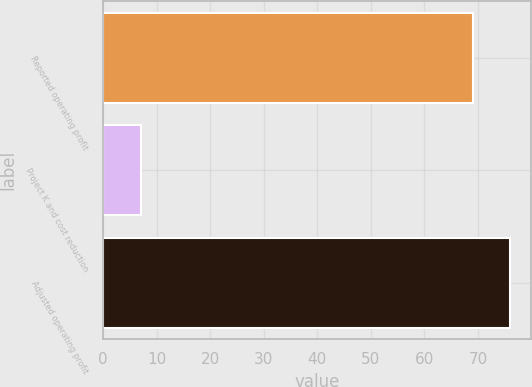<chart> <loc_0><loc_0><loc_500><loc_500><bar_chart><fcel>Reported operating profit<fcel>Project K and cost reduction<fcel>Adjusted operating profit<nl><fcel>69<fcel>7<fcel>76<nl></chart> 